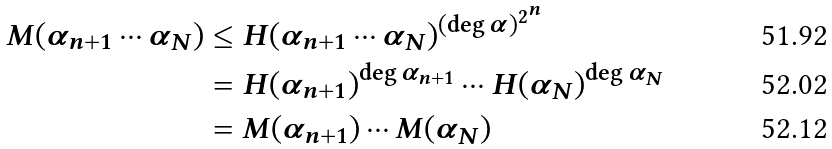<formula> <loc_0><loc_0><loc_500><loc_500>M ( \alpha _ { n + 1 } \cdots \alpha _ { N } ) & \leq H ( \alpha _ { n + 1 } \cdots \alpha _ { N } ) ^ { ( \deg \alpha ) ^ { 2 ^ { n } } } \\ & = H ( \alpha _ { n + 1 } ) ^ { \deg \alpha _ { n + 1 } } \cdots H ( \alpha _ { N } ) ^ { \deg \alpha _ { N } } \\ & = M ( \alpha _ { n + 1 } ) \cdots M ( \alpha _ { N } )</formula> 